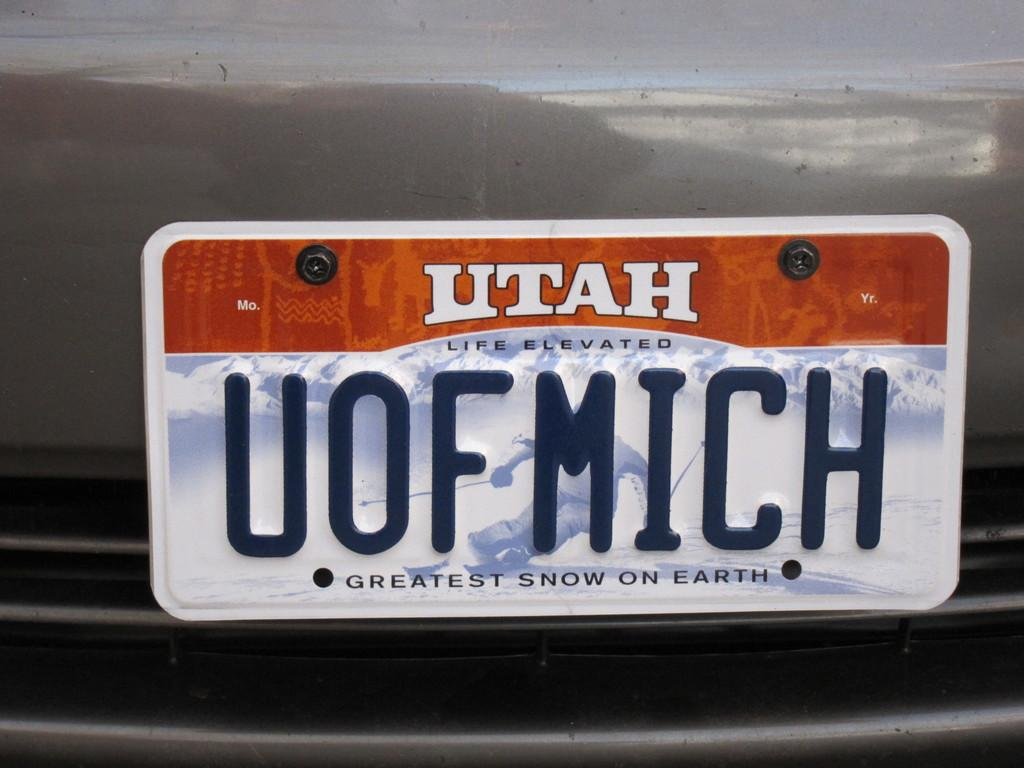<image>
Share a concise interpretation of the image provided. A car licence plate with the word Utah on it . 